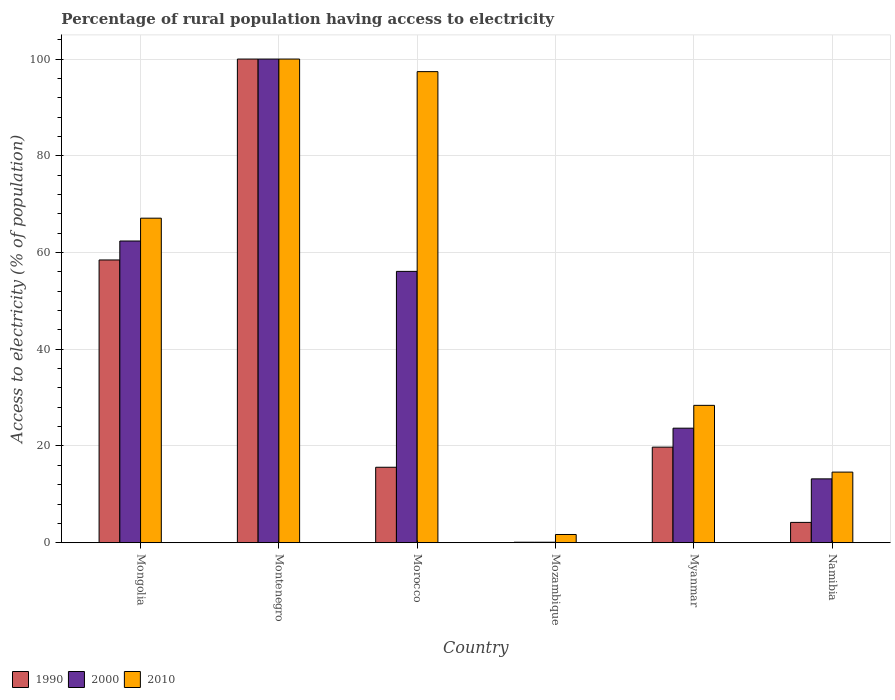How many groups of bars are there?
Keep it short and to the point. 6. Are the number of bars on each tick of the X-axis equal?
Your response must be concise. Yes. How many bars are there on the 1st tick from the left?
Your answer should be very brief. 3. What is the label of the 2nd group of bars from the left?
Your response must be concise. Montenegro. In how many cases, is the number of bars for a given country not equal to the number of legend labels?
Your response must be concise. 0. What is the percentage of rural population having access to electricity in 1990 in Montenegro?
Your answer should be very brief. 100. Across all countries, what is the maximum percentage of rural population having access to electricity in 2010?
Make the answer very short. 100. Across all countries, what is the minimum percentage of rural population having access to electricity in 2010?
Make the answer very short. 1.7. In which country was the percentage of rural population having access to electricity in 2010 maximum?
Ensure brevity in your answer.  Montenegro. In which country was the percentage of rural population having access to electricity in 1990 minimum?
Offer a very short reply. Mozambique. What is the total percentage of rural population having access to electricity in 1990 in the graph?
Ensure brevity in your answer.  198.12. What is the difference between the percentage of rural population having access to electricity in 1990 in Mozambique and that in Myanmar?
Give a very brief answer. -19.66. What is the average percentage of rural population having access to electricity in 2010 per country?
Keep it short and to the point. 51.53. What is the difference between the percentage of rural population having access to electricity of/in 1990 and percentage of rural population having access to electricity of/in 2000 in Myanmar?
Make the answer very short. -3.92. What is the ratio of the percentage of rural population having access to electricity in 1990 in Mongolia to that in Montenegro?
Your response must be concise. 0.58. Is the percentage of rural population having access to electricity in 2000 in Mongolia less than that in Montenegro?
Your answer should be compact. Yes. Is the difference between the percentage of rural population having access to electricity in 1990 in Morocco and Myanmar greater than the difference between the percentage of rural population having access to electricity in 2000 in Morocco and Myanmar?
Your answer should be compact. No. What is the difference between the highest and the second highest percentage of rural population having access to electricity in 2000?
Ensure brevity in your answer.  -43.9. What is the difference between the highest and the lowest percentage of rural population having access to electricity in 1990?
Ensure brevity in your answer.  99.9. In how many countries, is the percentage of rural population having access to electricity in 1990 greater than the average percentage of rural population having access to electricity in 1990 taken over all countries?
Provide a short and direct response. 2. Is the sum of the percentage of rural population having access to electricity in 2010 in Mongolia and Montenegro greater than the maximum percentage of rural population having access to electricity in 1990 across all countries?
Offer a very short reply. Yes. What does the 1st bar from the left in Mongolia represents?
Your answer should be compact. 1990. What does the 3rd bar from the right in Morocco represents?
Keep it short and to the point. 1990. Is it the case that in every country, the sum of the percentage of rural population having access to electricity in 2000 and percentage of rural population having access to electricity in 1990 is greater than the percentage of rural population having access to electricity in 2010?
Offer a terse response. No. Are all the bars in the graph horizontal?
Make the answer very short. No. How many countries are there in the graph?
Make the answer very short. 6. What is the difference between two consecutive major ticks on the Y-axis?
Provide a short and direct response. 20. How many legend labels are there?
Your answer should be very brief. 3. How are the legend labels stacked?
Your answer should be very brief. Horizontal. What is the title of the graph?
Keep it short and to the point. Percentage of rural population having access to electricity. Does "1983" appear as one of the legend labels in the graph?
Ensure brevity in your answer.  No. What is the label or title of the Y-axis?
Offer a very short reply. Access to electricity (% of population). What is the Access to electricity (% of population) of 1990 in Mongolia?
Keep it short and to the point. 58.46. What is the Access to electricity (% of population) in 2000 in Mongolia?
Provide a short and direct response. 62.38. What is the Access to electricity (% of population) of 2010 in Mongolia?
Provide a short and direct response. 67.1. What is the Access to electricity (% of population) in 1990 in Montenegro?
Make the answer very short. 100. What is the Access to electricity (% of population) of 2000 in Montenegro?
Your response must be concise. 100. What is the Access to electricity (% of population) in 2010 in Montenegro?
Provide a short and direct response. 100. What is the Access to electricity (% of population) of 1990 in Morocco?
Keep it short and to the point. 15.6. What is the Access to electricity (% of population) in 2000 in Morocco?
Offer a terse response. 56.1. What is the Access to electricity (% of population) of 2010 in Morocco?
Your answer should be very brief. 97.4. What is the Access to electricity (% of population) in 1990 in Mozambique?
Make the answer very short. 0.1. What is the Access to electricity (% of population) of 1990 in Myanmar?
Offer a terse response. 19.76. What is the Access to electricity (% of population) of 2000 in Myanmar?
Keep it short and to the point. 23.68. What is the Access to electricity (% of population) of 2010 in Myanmar?
Offer a very short reply. 28.4. What is the Access to electricity (% of population) of 1990 in Namibia?
Ensure brevity in your answer.  4.2. What is the Access to electricity (% of population) in 2010 in Namibia?
Your answer should be very brief. 14.6. Across all countries, what is the minimum Access to electricity (% of population) in 1990?
Your answer should be very brief. 0.1. Across all countries, what is the minimum Access to electricity (% of population) in 2010?
Your answer should be very brief. 1.7. What is the total Access to electricity (% of population) of 1990 in the graph?
Your response must be concise. 198.12. What is the total Access to electricity (% of population) of 2000 in the graph?
Make the answer very short. 255.46. What is the total Access to electricity (% of population) in 2010 in the graph?
Keep it short and to the point. 309.2. What is the difference between the Access to electricity (% of population) of 1990 in Mongolia and that in Montenegro?
Your answer should be compact. -41.54. What is the difference between the Access to electricity (% of population) in 2000 in Mongolia and that in Montenegro?
Give a very brief answer. -37.62. What is the difference between the Access to electricity (% of population) of 2010 in Mongolia and that in Montenegro?
Your answer should be very brief. -32.9. What is the difference between the Access to electricity (% of population) of 1990 in Mongolia and that in Morocco?
Give a very brief answer. 42.86. What is the difference between the Access to electricity (% of population) in 2000 in Mongolia and that in Morocco?
Provide a succinct answer. 6.28. What is the difference between the Access to electricity (% of population) of 2010 in Mongolia and that in Morocco?
Keep it short and to the point. -30.3. What is the difference between the Access to electricity (% of population) of 1990 in Mongolia and that in Mozambique?
Your answer should be very brief. 58.36. What is the difference between the Access to electricity (% of population) of 2000 in Mongolia and that in Mozambique?
Give a very brief answer. 62.28. What is the difference between the Access to electricity (% of population) in 2010 in Mongolia and that in Mozambique?
Make the answer very short. 65.4. What is the difference between the Access to electricity (% of population) of 1990 in Mongolia and that in Myanmar?
Keep it short and to the point. 38.7. What is the difference between the Access to electricity (% of population) in 2000 in Mongolia and that in Myanmar?
Make the answer very short. 38.7. What is the difference between the Access to electricity (% of population) in 2010 in Mongolia and that in Myanmar?
Keep it short and to the point. 38.7. What is the difference between the Access to electricity (% of population) of 1990 in Mongolia and that in Namibia?
Your answer should be very brief. 54.26. What is the difference between the Access to electricity (% of population) in 2000 in Mongolia and that in Namibia?
Your answer should be very brief. 49.18. What is the difference between the Access to electricity (% of population) of 2010 in Mongolia and that in Namibia?
Offer a terse response. 52.5. What is the difference between the Access to electricity (% of population) in 1990 in Montenegro and that in Morocco?
Give a very brief answer. 84.4. What is the difference between the Access to electricity (% of population) in 2000 in Montenegro and that in Morocco?
Offer a terse response. 43.9. What is the difference between the Access to electricity (% of population) in 2010 in Montenegro and that in Morocco?
Offer a terse response. 2.6. What is the difference between the Access to electricity (% of population) in 1990 in Montenegro and that in Mozambique?
Your answer should be compact. 99.9. What is the difference between the Access to electricity (% of population) in 2000 in Montenegro and that in Mozambique?
Make the answer very short. 99.9. What is the difference between the Access to electricity (% of population) in 2010 in Montenegro and that in Mozambique?
Offer a very short reply. 98.3. What is the difference between the Access to electricity (% of population) of 1990 in Montenegro and that in Myanmar?
Keep it short and to the point. 80.24. What is the difference between the Access to electricity (% of population) in 2000 in Montenegro and that in Myanmar?
Provide a short and direct response. 76.32. What is the difference between the Access to electricity (% of population) in 2010 in Montenegro and that in Myanmar?
Offer a very short reply. 71.6. What is the difference between the Access to electricity (% of population) of 1990 in Montenegro and that in Namibia?
Keep it short and to the point. 95.8. What is the difference between the Access to electricity (% of population) of 2000 in Montenegro and that in Namibia?
Provide a succinct answer. 86.8. What is the difference between the Access to electricity (% of population) in 2010 in Montenegro and that in Namibia?
Give a very brief answer. 85.4. What is the difference between the Access to electricity (% of population) of 1990 in Morocco and that in Mozambique?
Provide a short and direct response. 15.5. What is the difference between the Access to electricity (% of population) of 2000 in Morocco and that in Mozambique?
Your response must be concise. 56. What is the difference between the Access to electricity (% of population) of 2010 in Morocco and that in Mozambique?
Keep it short and to the point. 95.7. What is the difference between the Access to electricity (% of population) of 1990 in Morocco and that in Myanmar?
Provide a succinct answer. -4.16. What is the difference between the Access to electricity (% of population) in 2000 in Morocco and that in Myanmar?
Provide a succinct answer. 32.42. What is the difference between the Access to electricity (% of population) in 2000 in Morocco and that in Namibia?
Offer a terse response. 42.9. What is the difference between the Access to electricity (% of population) in 2010 in Morocco and that in Namibia?
Your response must be concise. 82.8. What is the difference between the Access to electricity (% of population) in 1990 in Mozambique and that in Myanmar?
Your response must be concise. -19.66. What is the difference between the Access to electricity (% of population) of 2000 in Mozambique and that in Myanmar?
Offer a terse response. -23.58. What is the difference between the Access to electricity (% of population) in 2010 in Mozambique and that in Myanmar?
Provide a short and direct response. -26.7. What is the difference between the Access to electricity (% of population) in 1990 in Mozambique and that in Namibia?
Your answer should be very brief. -4.1. What is the difference between the Access to electricity (% of population) of 2000 in Mozambique and that in Namibia?
Provide a succinct answer. -13.1. What is the difference between the Access to electricity (% of population) in 1990 in Myanmar and that in Namibia?
Make the answer very short. 15.56. What is the difference between the Access to electricity (% of population) in 2000 in Myanmar and that in Namibia?
Give a very brief answer. 10.48. What is the difference between the Access to electricity (% of population) in 2010 in Myanmar and that in Namibia?
Give a very brief answer. 13.8. What is the difference between the Access to electricity (% of population) in 1990 in Mongolia and the Access to electricity (% of population) in 2000 in Montenegro?
Give a very brief answer. -41.54. What is the difference between the Access to electricity (% of population) of 1990 in Mongolia and the Access to electricity (% of population) of 2010 in Montenegro?
Give a very brief answer. -41.54. What is the difference between the Access to electricity (% of population) of 2000 in Mongolia and the Access to electricity (% of population) of 2010 in Montenegro?
Keep it short and to the point. -37.62. What is the difference between the Access to electricity (% of population) of 1990 in Mongolia and the Access to electricity (% of population) of 2000 in Morocco?
Provide a short and direct response. 2.36. What is the difference between the Access to electricity (% of population) in 1990 in Mongolia and the Access to electricity (% of population) in 2010 in Morocco?
Ensure brevity in your answer.  -38.94. What is the difference between the Access to electricity (% of population) in 2000 in Mongolia and the Access to electricity (% of population) in 2010 in Morocco?
Give a very brief answer. -35.02. What is the difference between the Access to electricity (% of population) in 1990 in Mongolia and the Access to electricity (% of population) in 2000 in Mozambique?
Give a very brief answer. 58.36. What is the difference between the Access to electricity (% of population) in 1990 in Mongolia and the Access to electricity (% of population) in 2010 in Mozambique?
Give a very brief answer. 56.76. What is the difference between the Access to electricity (% of population) of 2000 in Mongolia and the Access to electricity (% of population) of 2010 in Mozambique?
Keep it short and to the point. 60.68. What is the difference between the Access to electricity (% of population) of 1990 in Mongolia and the Access to electricity (% of population) of 2000 in Myanmar?
Ensure brevity in your answer.  34.78. What is the difference between the Access to electricity (% of population) in 1990 in Mongolia and the Access to electricity (% of population) in 2010 in Myanmar?
Give a very brief answer. 30.06. What is the difference between the Access to electricity (% of population) of 2000 in Mongolia and the Access to electricity (% of population) of 2010 in Myanmar?
Your answer should be compact. 33.98. What is the difference between the Access to electricity (% of population) in 1990 in Mongolia and the Access to electricity (% of population) in 2000 in Namibia?
Keep it short and to the point. 45.26. What is the difference between the Access to electricity (% of population) of 1990 in Mongolia and the Access to electricity (% of population) of 2010 in Namibia?
Offer a terse response. 43.86. What is the difference between the Access to electricity (% of population) in 2000 in Mongolia and the Access to electricity (% of population) in 2010 in Namibia?
Your answer should be very brief. 47.78. What is the difference between the Access to electricity (% of population) in 1990 in Montenegro and the Access to electricity (% of population) in 2000 in Morocco?
Your answer should be compact. 43.9. What is the difference between the Access to electricity (% of population) of 2000 in Montenegro and the Access to electricity (% of population) of 2010 in Morocco?
Make the answer very short. 2.6. What is the difference between the Access to electricity (% of population) in 1990 in Montenegro and the Access to electricity (% of population) in 2000 in Mozambique?
Your answer should be very brief. 99.9. What is the difference between the Access to electricity (% of population) of 1990 in Montenegro and the Access to electricity (% of population) of 2010 in Mozambique?
Provide a succinct answer. 98.3. What is the difference between the Access to electricity (% of population) in 2000 in Montenegro and the Access to electricity (% of population) in 2010 in Mozambique?
Provide a short and direct response. 98.3. What is the difference between the Access to electricity (% of population) in 1990 in Montenegro and the Access to electricity (% of population) in 2000 in Myanmar?
Give a very brief answer. 76.32. What is the difference between the Access to electricity (% of population) of 1990 in Montenegro and the Access to electricity (% of population) of 2010 in Myanmar?
Make the answer very short. 71.6. What is the difference between the Access to electricity (% of population) of 2000 in Montenegro and the Access to electricity (% of population) of 2010 in Myanmar?
Make the answer very short. 71.6. What is the difference between the Access to electricity (% of population) of 1990 in Montenegro and the Access to electricity (% of population) of 2000 in Namibia?
Your answer should be compact. 86.8. What is the difference between the Access to electricity (% of population) in 1990 in Montenegro and the Access to electricity (% of population) in 2010 in Namibia?
Offer a terse response. 85.4. What is the difference between the Access to electricity (% of population) in 2000 in Montenegro and the Access to electricity (% of population) in 2010 in Namibia?
Your answer should be very brief. 85.4. What is the difference between the Access to electricity (% of population) of 1990 in Morocco and the Access to electricity (% of population) of 2000 in Mozambique?
Offer a terse response. 15.5. What is the difference between the Access to electricity (% of population) in 1990 in Morocco and the Access to electricity (% of population) in 2010 in Mozambique?
Make the answer very short. 13.9. What is the difference between the Access to electricity (% of population) of 2000 in Morocco and the Access to electricity (% of population) of 2010 in Mozambique?
Give a very brief answer. 54.4. What is the difference between the Access to electricity (% of population) of 1990 in Morocco and the Access to electricity (% of population) of 2000 in Myanmar?
Your response must be concise. -8.08. What is the difference between the Access to electricity (% of population) of 2000 in Morocco and the Access to electricity (% of population) of 2010 in Myanmar?
Provide a succinct answer. 27.7. What is the difference between the Access to electricity (% of population) in 1990 in Morocco and the Access to electricity (% of population) in 2000 in Namibia?
Your answer should be compact. 2.4. What is the difference between the Access to electricity (% of population) of 1990 in Morocco and the Access to electricity (% of population) of 2010 in Namibia?
Make the answer very short. 1. What is the difference between the Access to electricity (% of population) of 2000 in Morocco and the Access to electricity (% of population) of 2010 in Namibia?
Keep it short and to the point. 41.5. What is the difference between the Access to electricity (% of population) in 1990 in Mozambique and the Access to electricity (% of population) in 2000 in Myanmar?
Your answer should be very brief. -23.58. What is the difference between the Access to electricity (% of population) in 1990 in Mozambique and the Access to electricity (% of population) in 2010 in Myanmar?
Give a very brief answer. -28.3. What is the difference between the Access to electricity (% of population) in 2000 in Mozambique and the Access to electricity (% of population) in 2010 in Myanmar?
Keep it short and to the point. -28.3. What is the difference between the Access to electricity (% of population) of 1990 in Mozambique and the Access to electricity (% of population) of 2000 in Namibia?
Keep it short and to the point. -13.1. What is the difference between the Access to electricity (% of population) in 1990 in Myanmar and the Access to electricity (% of population) in 2000 in Namibia?
Provide a short and direct response. 6.56. What is the difference between the Access to electricity (% of population) in 1990 in Myanmar and the Access to electricity (% of population) in 2010 in Namibia?
Keep it short and to the point. 5.16. What is the difference between the Access to electricity (% of population) in 2000 in Myanmar and the Access to electricity (% of population) in 2010 in Namibia?
Offer a terse response. 9.08. What is the average Access to electricity (% of population) of 1990 per country?
Give a very brief answer. 33.02. What is the average Access to electricity (% of population) of 2000 per country?
Keep it short and to the point. 42.58. What is the average Access to electricity (% of population) of 2010 per country?
Provide a short and direct response. 51.53. What is the difference between the Access to electricity (% of population) in 1990 and Access to electricity (% of population) in 2000 in Mongolia?
Provide a succinct answer. -3.92. What is the difference between the Access to electricity (% of population) in 1990 and Access to electricity (% of population) in 2010 in Mongolia?
Give a very brief answer. -8.64. What is the difference between the Access to electricity (% of population) in 2000 and Access to electricity (% of population) in 2010 in Mongolia?
Your answer should be very brief. -4.72. What is the difference between the Access to electricity (% of population) in 1990 and Access to electricity (% of population) in 2000 in Montenegro?
Your response must be concise. 0. What is the difference between the Access to electricity (% of population) of 1990 and Access to electricity (% of population) of 2010 in Montenegro?
Offer a very short reply. 0. What is the difference between the Access to electricity (% of population) of 1990 and Access to electricity (% of population) of 2000 in Morocco?
Provide a short and direct response. -40.5. What is the difference between the Access to electricity (% of population) of 1990 and Access to electricity (% of population) of 2010 in Morocco?
Make the answer very short. -81.8. What is the difference between the Access to electricity (% of population) of 2000 and Access to electricity (% of population) of 2010 in Morocco?
Provide a short and direct response. -41.3. What is the difference between the Access to electricity (% of population) of 1990 and Access to electricity (% of population) of 2010 in Mozambique?
Make the answer very short. -1.6. What is the difference between the Access to electricity (% of population) of 2000 and Access to electricity (% of population) of 2010 in Mozambique?
Make the answer very short. -1.6. What is the difference between the Access to electricity (% of population) of 1990 and Access to electricity (% of population) of 2000 in Myanmar?
Make the answer very short. -3.92. What is the difference between the Access to electricity (% of population) of 1990 and Access to electricity (% of population) of 2010 in Myanmar?
Ensure brevity in your answer.  -8.64. What is the difference between the Access to electricity (% of population) of 2000 and Access to electricity (% of population) of 2010 in Myanmar?
Your answer should be compact. -4.72. What is the difference between the Access to electricity (% of population) of 1990 and Access to electricity (% of population) of 2010 in Namibia?
Keep it short and to the point. -10.4. What is the difference between the Access to electricity (% of population) of 2000 and Access to electricity (% of population) of 2010 in Namibia?
Keep it short and to the point. -1.4. What is the ratio of the Access to electricity (% of population) of 1990 in Mongolia to that in Montenegro?
Your answer should be compact. 0.58. What is the ratio of the Access to electricity (% of population) in 2000 in Mongolia to that in Montenegro?
Provide a succinct answer. 0.62. What is the ratio of the Access to electricity (% of population) of 2010 in Mongolia to that in Montenegro?
Your answer should be compact. 0.67. What is the ratio of the Access to electricity (% of population) in 1990 in Mongolia to that in Morocco?
Provide a short and direct response. 3.75. What is the ratio of the Access to electricity (% of population) of 2000 in Mongolia to that in Morocco?
Offer a very short reply. 1.11. What is the ratio of the Access to electricity (% of population) in 2010 in Mongolia to that in Morocco?
Your answer should be very brief. 0.69. What is the ratio of the Access to electricity (% of population) in 1990 in Mongolia to that in Mozambique?
Provide a succinct answer. 584.6. What is the ratio of the Access to electricity (% of population) of 2000 in Mongolia to that in Mozambique?
Your response must be concise. 623.81. What is the ratio of the Access to electricity (% of population) of 2010 in Mongolia to that in Mozambique?
Your answer should be compact. 39.47. What is the ratio of the Access to electricity (% of population) of 1990 in Mongolia to that in Myanmar?
Give a very brief answer. 2.96. What is the ratio of the Access to electricity (% of population) of 2000 in Mongolia to that in Myanmar?
Ensure brevity in your answer.  2.63. What is the ratio of the Access to electricity (% of population) in 2010 in Mongolia to that in Myanmar?
Ensure brevity in your answer.  2.36. What is the ratio of the Access to electricity (% of population) in 1990 in Mongolia to that in Namibia?
Provide a short and direct response. 13.92. What is the ratio of the Access to electricity (% of population) of 2000 in Mongolia to that in Namibia?
Provide a succinct answer. 4.73. What is the ratio of the Access to electricity (% of population) in 2010 in Mongolia to that in Namibia?
Your response must be concise. 4.6. What is the ratio of the Access to electricity (% of population) of 1990 in Montenegro to that in Morocco?
Give a very brief answer. 6.41. What is the ratio of the Access to electricity (% of population) of 2000 in Montenegro to that in Morocco?
Ensure brevity in your answer.  1.78. What is the ratio of the Access to electricity (% of population) in 2010 in Montenegro to that in Morocco?
Provide a short and direct response. 1.03. What is the ratio of the Access to electricity (% of population) in 2010 in Montenegro to that in Mozambique?
Keep it short and to the point. 58.82. What is the ratio of the Access to electricity (% of population) in 1990 in Montenegro to that in Myanmar?
Make the answer very short. 5.06. What is the ratio of the Access to electricity (% of population) of 2000 in Montenegro to that in Myanmar?
Provide a short and direct response. 4.22. What is the ratio of the Access to electricity (% of population) of 2010 in Montenegro to that in Myanmar?
Offer a terse response. 3.52. What is the ratio of the Access to electricity (% of population) in 1990 in Montenegro to that in Namibia?
Your response must be concise. 23.81. What is the ratio of the Access to electricity (% of population) of 2000 in Montenegro to that in Namibia?
Your answer should be very brief. 7.58. What is the ratio of the Access to electricity (% of population) in 2010 in Montenegro to that in Namibia?
Provide a short and direct response. 6.85. What is the ratio of the Access to electricity (% of population) in 1990 in Morocco to that in Mozambique?
Keep it short and to the point. 156. What is the ratio of the Access to electricity (% of population) in 2000 in Morocco to that in Mozambique?
Offer a very short reply. 561.01. What is the ratio of the Access to electricity (% of population) of 2010 in Morocco to that in Mozambique?
Your answer should be compact. 57.29. What is the ratio of the Access to electricity (% of population) of 1990 in Morocco to that in Myanmar?
Offer a terse response. 0.79. What is the ratio of the Access to electricity (% of population) in 2000 in Morocco to that in Myanmar?
Make the answer very short. 2.37. What is the ratio of the Access to electricity (% of population) in 2010 in Morocco to that in Myanmar?
Your answer should be compact. 3.43. What is the ratio of the Access to electricity (% of population) of 1990 in Morocco to that in Namibia?
Your answer should be compact. 3.71. What is the ratio of the Access to electricity (% of population) of 2000 in Morocco to that in Namibia?
Offer a terse response. 4.25. What is the ratio of the Access to electricity (% of population) of 2010 in Morocco to that in Namibia?
Your response must be concise. 6.67. What is the ratio of the Access to electricity (% of population) of 1990 in Mozambique to that in Myanmar?
Offer a terse response. 0.01. What is the ratio of the Access to electricity (% of population) in 2000 in Mozambique to that in Myanmar?
Offer a terse response. 0. What is the ratio of the Access to electricity (% of population) of 2010 in Mozambique to that in Myanmar?
Keep it short and to the point. 0.06. What is the ratio of the Access to electricity (% of population) in 1990 in Mozambique to that in Namibia?
Keep it short and to the point. 0.02. What is the ratio of the Access to electricity (% of population) of 2000 in Mozambique to that in Namibia?
Make the answer very short. 0.01. What is the ratio of the Access to electricity (% of population) in 2010 in Mozambique to that in Namibia?
Offer a terse response. 0.12. What is the ratio of the Access to electricity (% of population) of 1990 in Myanmar to that in Namibia?
Offer a terse response. 4.7. What is the ratio of the Access to electricity (% of population) in 2000 in Myanmar to that in Namibia?
Your response must be concise. 1.79. What is the ratio of the Access to electricity (% of population) in 2010 in Myanmar to that in Namibia?
Give a very brief answer. 1.95. What is the difference between the highest and the second highest Access to electricity (% of population) of 1990?
Offer a terse response. 41.54. What is the difference between the highest and the second highest Access to electricity (% of population) of 2000?
Keep it short and to the point. 37.62. What is the difference between the highest and the second highest Access to electricity (% of population) of 2010?
Give a very brief answer. 2.6. What is the difference between the highest and the lowest Access to electricity (% of population) of 1990?
Your answer should be very brief. 99.9. What is the difference between the highest and the lowest Access to electricity (% of population) of 2000?
Offer a very short reply. 99.9. What is the difference between the highest and the lowest Access to electricity (% of population) in 2010?
Keep it short and to the point. 98.3. 